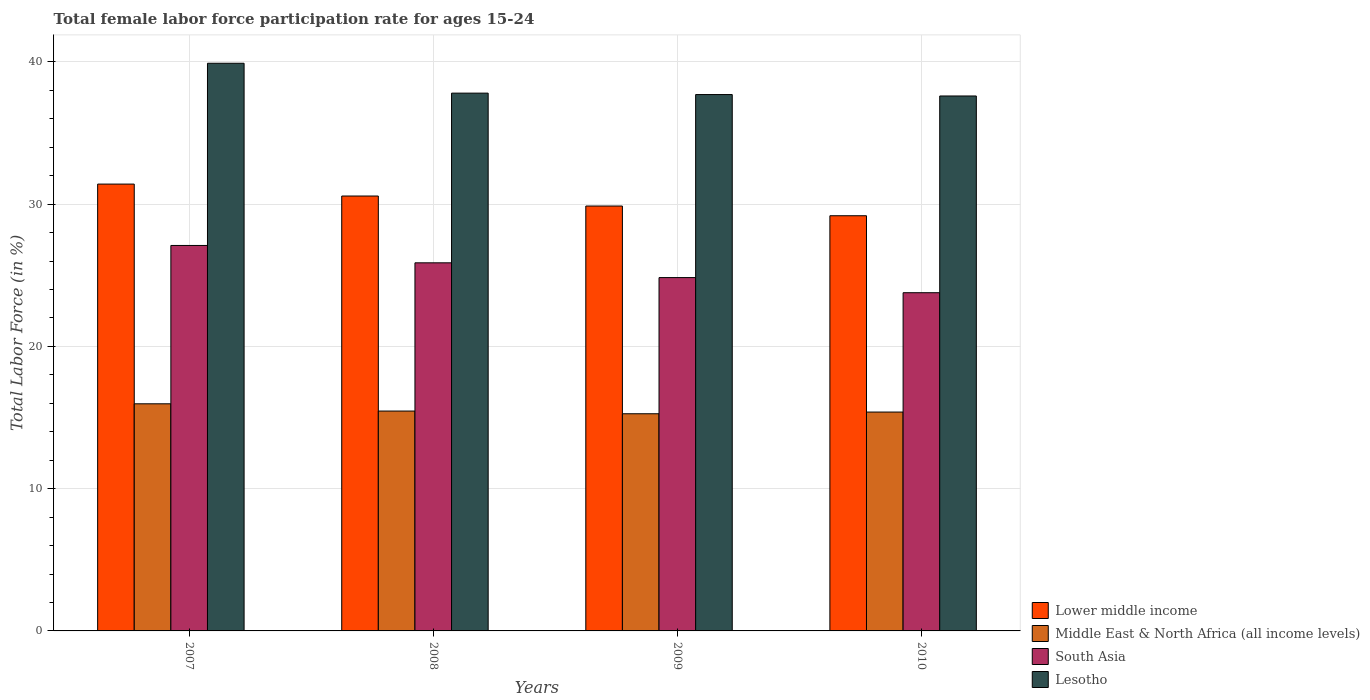How many different coloured bars are there?
Offer a terse response. 4. How many groups of bars are there?
Your answer should be compact. 4. Are the number of bars per tick equal to the number of legend labels?
Make the answer very short. Yes. How many bars are there on the 3rd tick from the right?
Your answer should be compact. 4. In how many cases, is the number of bars for a given year not equal to the number of legend labels?
Your response must be concise. 0. What is the female labor force participation rate in Lesotho in 2007?
Give a very brief answer. 39.9. Across all years, what is the maximum female labor force participation rate in Lower middle income?
Provide a succinct answer. 31.41. Across all years, what is the minimum female labor force participation rate in Lower middle income?
Give a very brief answer. 29.18. In which year was the female labor force participation rate in South Asia maximum?
Provide a succinct answer. 2007. In which year was the female labor force participation rate in South Asia minimum?
Provide a succinct answer. 2010. What is the total female labor force participation rate in Lower middle income in the graph?
Keep it short and to the point. 121.02. What is the difference between the female labor force participation rate in Middle East & North Africa (all income levels) in 2007 and that in 2009?
Make the answer very short. 0.7. What is the difference between the female labor force participation rate in Lesotho in 2010 and the female labor force participation rate in South Asia in 2009?
Provide a succinct answer. 12.76. What is the average female labor force participation rate in Lesotho per year?
Offer a terse response. 38.25. In the year 2007, what is the difference between the female labor force participation rate in Middle East & North Africa (all income levels) and female labor force participation rate in Lesotho?
Provide a succinct answer. -23.94. In how many years, is the female labor force participation rate in Lesotho greater than 28 %?
Make the answer very short. 4. What is the ratio of the female labor force participation rate in South Asia in 2008 to that in 2009?
Provide a succinct answer. 1.04. What is the difference between the highest and the second highest female labor force participation rate in Lesotho?
Your response must be concise. 2.1. What is the difference between the highest and the lowest female labor force participation rate in Middle East & North Africa (all income levels)?
Your answer should be compact. 0.7. Is it the case that in every year, the sum of the female labor force participation rate in Middle East & North Africa (all income levels) and female labor force participation rate in South Asia is greater than the sum of female labor force participation rate in Lower middle income and female labor force participation rate in Lesotho?
Ensure brevity in your answer.  No. What does the 2nd bar from the right in 2007 represents?
Give a very brief answer. South Asia. Is it the case that in every year, the sum of the female labor force participation rate in Lesotho and female labor force participation rate in South Asia is greater than the female labor force participation rate in Middle East & North Africa (all income levels)?
Your answer should be compact. Yes. Are all the bars in the graph horizontal?
Provide a succinct answer. No. How many years are there in the graph?
Provide a short and direct response. 4. Are the values on the major ticks of Y-axis written in scientific E-notation?
Keep it short and to the point. No. Where does the legend appear in the graph?
Make the answer very short. Bottom right. How are the legend labels stacked?
Make the answer very short. Vertical. What is the title of the graph?
Your response must be concise. Total female labor force participation rate for ages 15-24. Does "Serbia" appear as one of the legend labels in the graph?
Give a very brief answer. No. What is the label or title of the Y-axis?
Your response must be concise. Total Labor Force (in %). What is the Total Labor Force (in %) in Lower middle income in 2007?
Provide a short and direct response. 31.41. What is the Total Labor Force (in %) in Middle East & North Africa (all income levels) in 2007?
Offer a very short reply. 15.96. What is the Total Labor Force (in %) of South Asia in 2007?
Your response must be concise. 27.09. What is the Total Labor Force (in %) in Lesotho in 2007?
Provide a succinct answer. 39.9. What is the Total Labor Force (in %) in Lower middle income in 2008?
Make the answer very short. 30.57. What is the Total Labor Force (in %) in Middle East & North Africa (all income levels) in 2008?
Provide a succinct answer. 15.45. What is the Total Labor Force (in %) in South Asia in 2008?
Provide a succinct answer. 25.87. What is the Total Labor Force (in %) in Lesotho in 2008?
Ensure brevity in your answer.  37.8. What is the Total Labor Force (in %) of Lower middle income in 2009?
Your answer should be very brief. 29.86. What is the Total Labor Force (in %) of Middle East & North Africa (all income levels) in 2009?
Provide a short and direct response. 15.26. What is the Total Labor Force (in %) in South Asia in 2009?
Provide a short and direct response. 24.84. What is the Total Labor Force (in %) in Lesotho in 2009?
Give a very brief answer. 37.7. What is the Total Labor Force (in %) in Lower middle income in 2010?
Give a very brief answer. 29.18. What is the Total Labor Force (in %) in Middle East & North Africa (all income levels) in 2010?
Your response must be concise. 15.38. What is the Total Labor Force (in %) of South Asia in 2010?
Your answer should be very brief. 23.77. What is the Total Labor Force (in %) in Lesotho in 2010?
Make the answer very short. 37.6. Across all years, what is the maximum Total Labor Force (in %) of Lower middle income?
Offer a terse response. 31.41. Across all years, what is the maximum Total Labor Force (in %) of Middle East & North Africa (all income levels)?
Keep it short and to the point. 15.96. Across all years, what is the maximum Total Labor Force (in %) in South Asia?
Ensure brevity in your answer.  27.09. Across all years, what is the maximum Total Labor Force (in %) in Lesotho?
Ensure brevity in your answer.  39.9. Across all years, what is the minimum Total Labor Force (in %) of Lower middle income?
Provide a succinct answer. 29.18. Across all years, what is the minimum Total Labor Force (in %) in Middle East & North Africa (all income levels)?
Your response must be concise. 15.26. Across all years, what is the minimum Total Labor Force (in %) in South Asia?
Your answer should be compact. 23.77. Across all years, what is the minimum Total Labor Force (in %) in Lesotho?
Make the answer very short. 37.6. What is the total Total Labor Force (in %) of Lower middle income in the graph?
Offer a terse response. 121.02. What is the total Total Labor Force (in %) in Middle East & North Africa (all income levels) in the graph?
Your response must be concise. 62.07. What is the total Total Labor Force (in %) of South Asia in the graph?
Give a very brief answer. 101.57. What is the total Total Labor Force (in %) in Lesotho in the graph?
Your answer should be compact. 153. What is the difference between the Total Labor Force (in %) in Lower middle income in 2007 and that in 2008?
Offer a very short reply. 0.84. What is the difference between the Total Labor Force (in %) of Middle East & North Africa (all income levels) in 2007 and that in 2008?
Offer a terse response. 0.51. What is the difference between the Total Labor Force (in %) in South Asia in 2007 and that in 2008?
Provide a short and direct response. 1.22. What is the difference between the Total Labor Force (in %) of Lower middle income in 2007 and that in 2009?
Ensure brevity in your answer.  1.54. What is the difference between the Total Labor Force (in %) in Middle East & North Africa (all income levels) in 2007 and that in 2009?
Your response must be concise. 0.7. What is the difference between the Total Labor Force (in %) of South Asia in 2007 and that in 2009?
Your answer should be very brief. 2.26. What is the difference between the Total Labor Force (in %) of Lesotho in 2007 and that in 2009?
Make the answer very short. 2.2. What is the difference between the Total Labor Force (in %) of Lower middle income in 2007 and that in 2010?
Ensure brevity in your answer.  2.23. What is the difference between the Total Labor Force (in %) in Middle East & North Africa (all income levels) in 2007 and that in 2010?
Your response must be concise. 0.58. What is the difference between the Total Labor Force (in %) of South Asia in 2007 and that in 2010?
Offer a terse response. 3.32. What is the difference between the Total Labor Force (in %) of Lower middle income in 2008 and that in 2009?
Make the answer very short. 0.7. What is the difference between the Total Labor Force (in %) in Middle East & North Africa (all income levels) in 2008 and that in 2009?
Offer a terse response. 0.19. What is the difference between the Total Labor Force (in %) of South Asia in 2008 and that in 2009?
Your response must be concise. 1.04. What is the difference between the Total Labor Force (in %) of Lesotho in 2008 and that in 2009?
Your response must be concise. 0.1. What is the difference between the Total Labor Force (in %) in Lower middle income in 2008 and that in 2010?
Your answer should be compact. 1.39. What is the difference between the Total Labor Force (in %) of Middle East & North Africa (all income levels) in 2008 and that in 2010?
Your answer should be compact. 0.07. What is the difference between the Total Labor Force (in %) in South Asia in 2008 and that in 2010?
Keep it short and to the point. 2.1. What is the difference between the Total Labor Force (in %) of Lesotho in 2008 and that in 2010?
Offer a terse response. 0.2. What is the difference between the Total Labor Force (in %) of Lower middle income in 2009 and that in 2010?
Your response must be concise. 0.68. What is the difference between the Total Labor Force (in %) of Middle East & North Africa (all income levels) in 2009 and that in 2010?
Keep it short and to the point. -0.12. What is the difference between the Total Labor Force (in %) of South Asia in 2009 and that in 2010?
Make the answer very short. 1.06. What is the difference between the Total Labor Force (in %) of Lower middle income in 2007 and the Total Labor Force (in %) of Middle East & North Africa (all income levels) in 2008?
Your answer should be very brief. 15.95. What is the difference between the Total Labor Force (in %) in Lower middle income in 2007 and the Total Labor Force (in %) in South Asia in 2008?
Offer a very short reply. 5.53. What is the difference between the Total Labor Force (in %) in Lower middle income in 2007 and the Total Labor Force (in %) in Lesotho in 2008?
Ensure brevity in your answer.  -6.39. What is the difference between the Total Labor Force (in %) of Middle East & North Africa (all income levels) in 2007 and the Total Labor Force (in %) of South Asia in 2008?
Your response must be concise. -9.91. What is the difference between the Total Labor Force (in %) in Middle East & North Africa (all income levels) in 2007 and the Total Labor Force (in %) in Lesotho in 2008?
Keep it short and to the point. -21.84. What is the difference between the Total Labor Force (in %) in South Asia in 2007 and the Total Labor Force (in %) in Lesotho in 2008?
Give a very brief answer. -10.71. What is the difference between the Total Labor Force (in %) in Lower middle income in 2007 and the Total Labor Force (in %) in Middle East & North Africa (all income levels) in 2009?
Provide a short and direct response. 16.14. What is the difference between the Total Labor Force (in %) in Lower middle income in 2007 and the Total Labor Force (in %) in South Asia in 2009?
Provide a succinct answer. 6.57. What is the difference between the Total Labor Force (in %) of Lower middle income in 2007 and the Total Labor Force (in %) of Lesotho in 2009?
Ensure brevity in your answer.  -6.29. What is the difference between the Total Labor Force (in %) of Middle East & North Africa (all income levels) in 2007 and the Total Labor Force (in %) of South Asia in 2009?
Ensure brevity in your answer.  -8.87. What is the difference between the Total Labor Force (in %) in Middle East & North Africa (all income levels) in 2007 and the Total Labor Force (in %) in Lesotho in 2009?
Offer a very short reply. -21.74. What is the difference between the Total Labor Force (in %) of South Asia in 2007 and the Total Labor Force (in %) of Lesotho in 2009?
Your answer should be compact. -10.61. What is the difference between the Total Labor Force (in %) in Lower middle income in 2007 and the Total Labor Force (in %) in Middle East & North Africa (all income levels) in 2010?
Your answer should be compact. 16.02. What is the difference between the Total Labor Force (in %) of Lower middle income in 2007 and the Total Labor Force (in %) of South Asia in 2010?
Offer a terse response. 7.63. What is the difference between the Total Labor Force (in %) of Lower middle income in 2007 and the Total Labor Force (in %) of Lesotho in 2010?
Offer a very short reply. -6.19. What is the difference between the Total Labor Force (in %) of Middle East & North Africa (all income levels) in 2007 and the Total Labor Force (in %) of South Asia in 2010?
Ensure brevity in your answer.  -7.81. What is the difference between the Total Labor Force (in %) in Middle East & North Africa (all income levels) in 2007 and the Total Labor Force (in %) in Lesotho in 2010?
Offer a terse response. -21.64. What is the difference between the Total Labor Force (in %) of South Asia in 2007 and the Total Labor Force (in %) of Lesotho in 2010?
Make the answer very short. -10.51. What is the difference between the Total Labor Force (in %) of Lower middle income in 2008 and the Total Labor Force (in %) of Middle East & North Africa (all income levels) in 2009?
Keep it short and to the point. 15.3. What is the difference between the Total Labor Force (in %) of Lower middle income in 2008 and the Total Labor Force (in %) of South Asia in 2009?
Make the answer very short. 5.73. What is the difference between the Total Labor Force (in %) in Lower middle income in 2008 and the Total Labor Force (in %) in Lesotho in 2009?
Provide a short and direct response. -7.13. What is the difference between the Total Labor Force (in %) of Middle East & North Africa (all income levels) in 2008 and the Total Labor Force (in %) of South Asia in 2009?
Provide a succinct answer. -9.38. What is the difference between the Total Labor Force (in %) of Middle East & North Africa (all income levels) in 2008 and the Total Labor Force (in %) of Lesotho in 2009?
Your answer should be compact. -22.25. What is the difference between the Total Labor Force (in %) of South Asia in 2008 and the Total Labor Force (in %) of Lesotho in 2009?
Provide a succinct answer. -11.83. What is the difference between the Total Labor Force (in %) of Lower middle income in 2008 and the Total Labor Force (in %) of Middle East & North Africa (all income levels) in 2010?
Your response must be concise. 15.18. What is the difference between the Total Labor Force (in %) of Lower middle income in 2008 and the Total Labor Force (in %) of South Asia in 2010?
Give a very brief answer. 6.8. What is the difference between the Total Labor Force (in %) of Lower middle income in 2008 and the Total Labor Force (in %) of Lesotho in 2010?
Give a very brief answer. -7.03. What is the difference between the Total Labor Force (in %) in Middle East & North Africa (all income levels) in 2008 and the Total Labor Force (in %) in South Asia in 2010?
Keep it short and to the point. -8.32. What is the difference between the Total Labor Force (in %) of Middle East & North Africa (all income levels) in 2008 and the Total Labor Force (in %) of Lesotho in 2010?
Make the answer very short. -22.15. What is the difference between the Total Labor Force (in %) of South Asia in 2008 and the Total Labor Force (in %) of Lesotho in 2010?
Your answer should be very brief. -11.73. What is the difference between the Total Labor Force (in %) in Lower middle income in 2009 and the Total Labor Force (in %) in Middle East & North Africa (all income levels) in 2010?
Your response must be concise. 14.48. What is the difference between the Total Labor Force (in %) of Lower middle income in 2009 and the Total Labor Force (in %) of South Asia in 2010?
Give a very brief answer. 6.09. What is the difference between the Total Labor Force (in %) of Lower middle income in 2009 and the Total Labor Force (in %) of Lesotho in 2010?
Your answer should be very brief. -7.74. What is the difference between the Total Labor Force (in %) in Middle East & North Africa (all income levels) in 2009 and the Total Labor Force (in %) in South Asia in 2010?
Provide a short and direct response. -8.51. What is the difference between the Total Labor Force (in %) in Middle East & North Africa (all income levels) in 2009 and the Total Labor Force (in %) in Lesotho in 2010?
Make the answer very short. -22.34. What is the difference between the Total Labor Force (in %) in South Asia in 2009 and the Total Labor Force (in %) in Lesotho in 2010?
Provide a succinct answer. -12.76. What is the average Total Labor Force (in %) of Lower middle income per year?
Provide a succinct answer. 30.26. What is the average Total Labor Force (in %) in Middle East & North Africa (all income levels) per year?
Keep it short and to the point. 15.52. What is the average Total Labor Force (in %) in South Asia per year?
Offer a very short reply. 25.39. What is the average Total Labor Force (in %) of Lesotho per year?
Your response must be concise. 38.25. In the year 2007, what is the difference between the Total Labor Force (in %) of Lower middle income and Total Labor Force (in %) of Middle East & North Africa (all income levels)?
Offer a terse response. 15.44. In the year 2007, what is the difference between the Total Labor Force (in %) in Lower middle income and Total Labor Force (in %) in South Asia?
Ensure brevity in your answer.  4.31. In the year 2007, what is the difference between the Total Labor Force (in %) in Lower middle income and Total Labor Force (in %) in Lesotho?
Provide a succinct answer. -8.49. In the year 2007, what is the difference between the Total Labor Force (in %) of Middle East & North Africa (all income levels) and Total Labor Force (in %) of South Asia?
Ensure brevity in your answer.  -11.13. In the year 2007, what is the difference between the Total Labor Force (in %) in Middle East & North Africa (all income levels) and Total Labor Force (in %) in Lesotho?
Offer a very short reply. -23.94. In the year 2007, what is the difference between the Total Labor Force (in %) in South Asia and Total Labor Force (in %) in Lesotho?
Give a very brief answer. -12.81. In the year 2008, what is the difference between the Total Labor Force (in %) of Lower middle income and Total Labor Force (in %) of Middle East & North Africa (all income levels)?
Your answer should be compact. 15.11. In the year 2008, what is the difference between the Total Labor Force (in %) of Lower middle income and Total Labor Force (in %) of South Asia?
Keep it short and to the point. 4.69. In the year 2008, what is the difference between the Total Labor Force (in %) in Lower middle income and Total Labor Force (in %) in Lesotho?
Offer a very short reply. -7.23. In the year 2008, what is the difference between the Total Labor Force (in %) in Middle East & North Africa (all income levels) and Total Labor Force (in %) in South Asia?
Your response must be concise. -10.42. In the year 2008, what is the difference between the Total Labor Force (in %) of Middle East & North Africa (all income levels) and Total Labor Force (in %) of Lesotho?
Your answer should be compact. -22.35. In the year 2008, what is the difference between the Total Labor Force (in %) in South Asia and Total Labor Force (in %) in Lesotho?
Your answer should be compact. -11.93. In the year 2009, what is the difference between the Total Labor Force (in %) in Lower middle income and Total Labor Force (in %) in Middle East & North Africa (all income levels)?
Provide a short and direct response. 14.6. In the year 2009, what is the difference between the Total Labor Force (in %) of Lower middle income and Total Labor Force (in %) of South Asia?
Keep it short and to the point. 5.03. In the year 2009, what is the difference between the Total Labor Force (in %) in Lower middle income and Total Labor Force (in %) in Lesotho?
Provide a short and direct response. -7.83. In the year 2009, what is the difference between the Total Labor Force (in %) in Middle East & North Africa (all income levels) and Total Labor Force (in %) in South Asia?
Give a very brief answer. -9.57. In the year 2009, what is the difference between the Total Labor Force (in %) of Middle East & North Africa (all income levels) and Total Labor Force (in %) of Lesotho?
Make the answer very short. -22.44. In the year 2009, what is the difference between the Total Labor Force (in %) of South Asia and Total Labor Force (in %) of Lesotho?
Your answer should be very brief. -12.86. In the year 2010, what is the difference between the Total Labor Force (in %) of Lower middle income and Total Labor Force (in %) of Middle East & North Africa (all income levels)?
Offer a terse response. 13.8. In the year 2010, what is the difference between the Total Labor Force (in %) in Lower middle income and Total Labor Force (in %) in South Asia?
Offer a terse response. 5.41. In the year 2010, what is the difference between the Total Labor Force (in %) in Lower middle income and Total Labor Force (in %) in Lesotho?
Give a very brief answer. -8.42. In the year 2010, what is the difference between the Total Labor Force (in %) of Middle East & North Africa (all income levels) and Total Labor Force (in %) of South Asia?
Your answer should be compact. -8.39. In the year 2010, what is the difference between the Total Labor Force (in %) of Middle East & North Africa (all income levels) and Total Labor Force (in %) of Lesotho?
Offer a terse response. -22.22. In the year 2010, what is the difference between the Total Labor Force (in %) of South Asia and Total Labor Force (in %) of Lesotho?
Ensure brevity in your answer.  -13.83. What is the ratio of the Total Labor Force (in %) in Lower middle income in 2007 to that in 2008?
Your answer should be compact. 1.03. What is the ratio of the Total Labor Force (in %) in Middle East & North Africa (all income levels) in 2007 to that in 2008?
Keep it short and to the point. 1.03. What is the ratio of the Total Labor Force (in %) in South Asia in 2007 to that in 2008?
Provide a succinct answer. 1.05. What is the ratio of the Total Labor Force (in %) in Lesotho in 2007 to that in 2008?
Your answer should be very brief. 1.06. What is the ratio of the Total Labor Force (in %) of Lower middle income in 2007 to that in 2009?
Your response must be concise. 1.05. What is the ratio of the Total Labor Force (in %) in Middle East & North Africa (all income levels) in 2007 to that in 2009?
Provide a succinct answer. 1.05. What is the ratio of the Total Labor Force (in %) of Lesotho in 2007 to that in 2009?
Provide a short and direct response. 1.06. What is the ratio of the Total Labor Force (in %) of Lower middle income in 2007 to that in 2010?
Your answer should be very brief. 1.08. What is the ratio of the Total Labor Force (in %) in Middle East & North Africa (all income levels) in 2007 to that in 2010?
Keep it short and to the point. 1.04. What is the ratio of the Total Labor Force (in %) of South Asia in 2007 to that in 2010?
Offer a terse response. 1.14. What is the ratio of the Total Labor Force (in %) of Lesotho in 2007 to that in 2010?
Offer a terse response. 1.06. What is the ratio of the Total Labor Force (in %) in Lower middle income in 2008 to that in 2009?
Make the answer very short. 1.02. What is the ratio of the Total Labor Force (in %) of Middle East & North Africa (all income levels) in 2008 to that in 2009?
Ensure brevity in your answer.  1.01. What is the ratio of the Total Labor Force (in %) of South Asia in 2008 to that in 2009?
Provide a succinct answer. 1.04. What is the ratio of the Total Labor Force (in %) in Lesotho in 2008 to that in 2009?
Your answer should be compact. 1. What is the ratio of the Total Labor Force (in %) of Lower middle income in 2008 to that in 2010?
Your answer should be compact. 1.05. What is the ratio of the Total Labor Force (in %) of Middle East & North Africa (all income levels) in 2008 to that in 2010?
Your answer should be very brief. 1. What is the ratio of the Total Labor Force (in %) of South Asia in 2008 to that in 2010?
Give a very brief answer. 1.09. What is the ratio of the Total Labor Force (in %) in Lower middle income in 2009 to that in 2010?
Keep it short and to the point. 1.02. What is the ratio of the Total Labor Force (in %) of Middle East & North Africa (all income levels) in 2009 to that in 2010?
Your answer should be very brief. 0.99. What is the ratio of the Total Labor Force (in %) of South Asia in 2009 to that in 2010?
Offer a terse response. 1.04. What is the ratio of the Total Labor Force (in %) in Lesotho in 2009 to that in 2010?
Your answer should be compact. 1. What is the difference between the highest and the second highest Total Labor Force (in %) in Lower middle income?
Offer a very short reply. 0.84. What is the difference between the highest and the second highest Total Labor Force (in %) in Middle East & North Africa (all income levels)?
Provide a succinct answer. 0.51. What is the difference between the highest and the second highest Total Labor Force (in %) in South Asia?
Offer a very short reply. 1.22. What is the difference between the highest and the second highest Total Labor Force (in %) of Lesotho?
Your answer should be very brief. 2.1. What is the difference between the highest and the lowest Total Labor Force (in %) of Lower middle income?
Keep it short and to the point. 2.23. What is the difference between the highest and the lowest Total Labor Force (in %) of Middle East & North Africa (all income levels)?
Provide a short and direct response. 0.7. What is the difference between the highest and the lowest Total Labor Force (in %) of South Asia?
Your answer should be very brief. 3.32. What is the difference between the highest and the lowest Total Labor Force (in %) in Lesotho?
Provide a short and direct response. 2.3. 